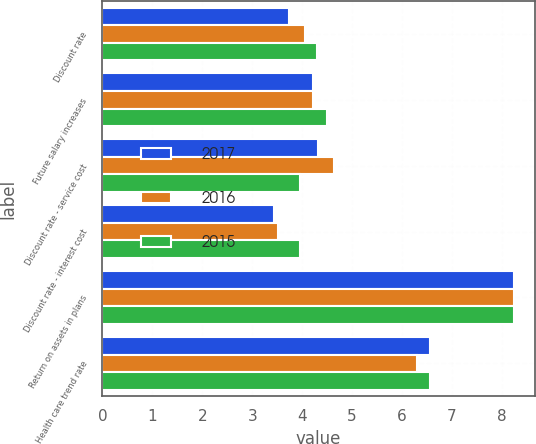Convert chart to OTSL. <chart><loc_0><loc_0><loc_500><loc_500><stacked_bar_chart><ecel><fcel>Discount rate<fcel>Future salary increases<fcel>Discount rate - service cost<fcel>Discount rate - interest cost<fcel>Return on assets in plans<fcel>Health care trend rate<nl><fcel>2017<fcel>3.74<fcel>4.21<fcel>4.31<fcel>3.43<fcel>8.25<fcel>6.56<nl><fcel>2016<fcel>4.05<fcel>4.21<fcel>4.64<fcel>3.51<fcel>8.25<fcel>6.3<nl><fcel>2015<fcel>4.3<fcel>4.5<fcel>3.95<fcel>3.95<fcel>8.25<fcel>6.56<nl></chart> 